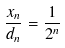<formula> <loc_0><loc_0><loc_500><loc_500>\frac { x _ { n } } { d _ { n } } = \frac { 1 } { 2 ^ { n } }</formula> 